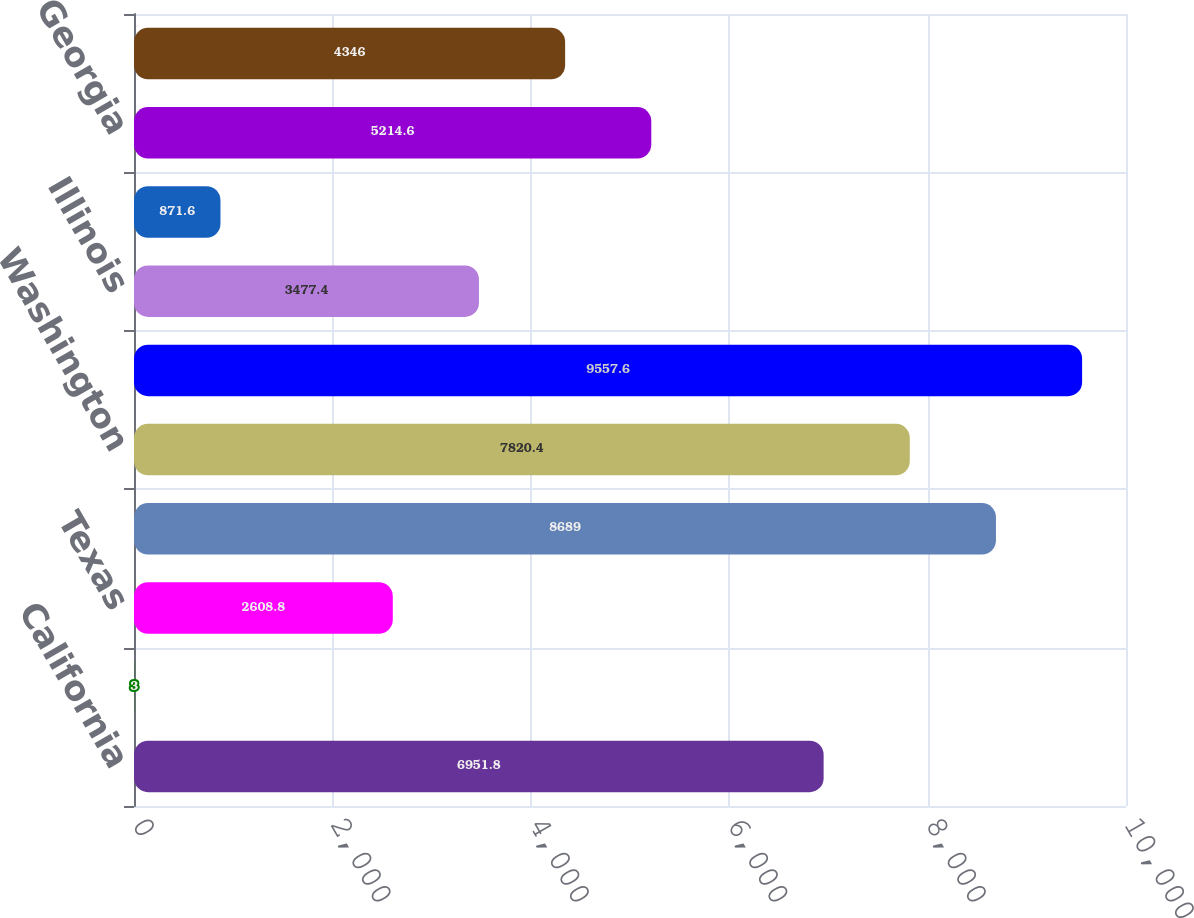Convert chart to OTSL. <chart><loc_0><loc_0><loc_500><loc_500><bar_chart><fcel>California<fcel>New York<fcel>Texas<fcel>Florida<fcel>Washington<fcel>Massachusetts<fcel>Illinois<fcel>New Jersey<fcel>Georgia<fcel>Ohio<nl><fcel>6951.8<fcel>3<fcel>2608.8<fcel>8689<fcel>7820.4<fcel>9557.6<fcel>3477.4<fcel>871.6<fcel>5214.6<fcel>4346<nl></chart> 